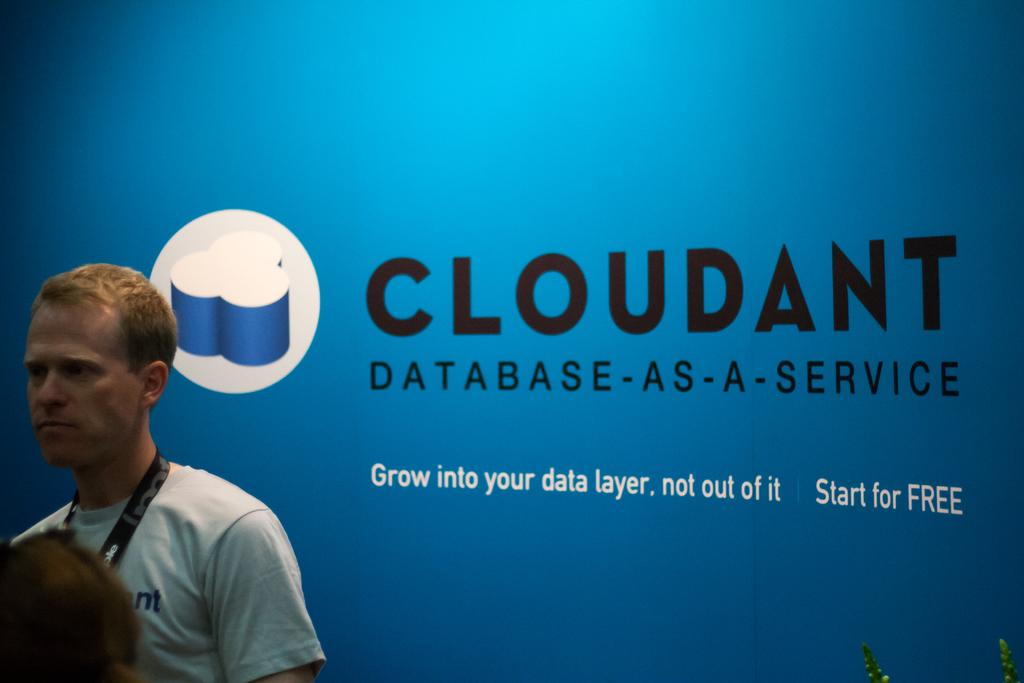Who or what is on the left side of the image? There is a person on the left side of the image. What can be observed about the person's attire? The person is wearing a tag. What color is the wall in the background of the image? There is a blue wall in the background of the image. What is written or depicted on the blue wall? Something is written on the blue wall. What type of symbol or design is visible in the image? There is a logo visible in the image. What type of jeans is the person wearing in the image? There is no information about the person's jeans in the image. How many planes can be seen flying in the background of the image? There are no planes visible in the image. 